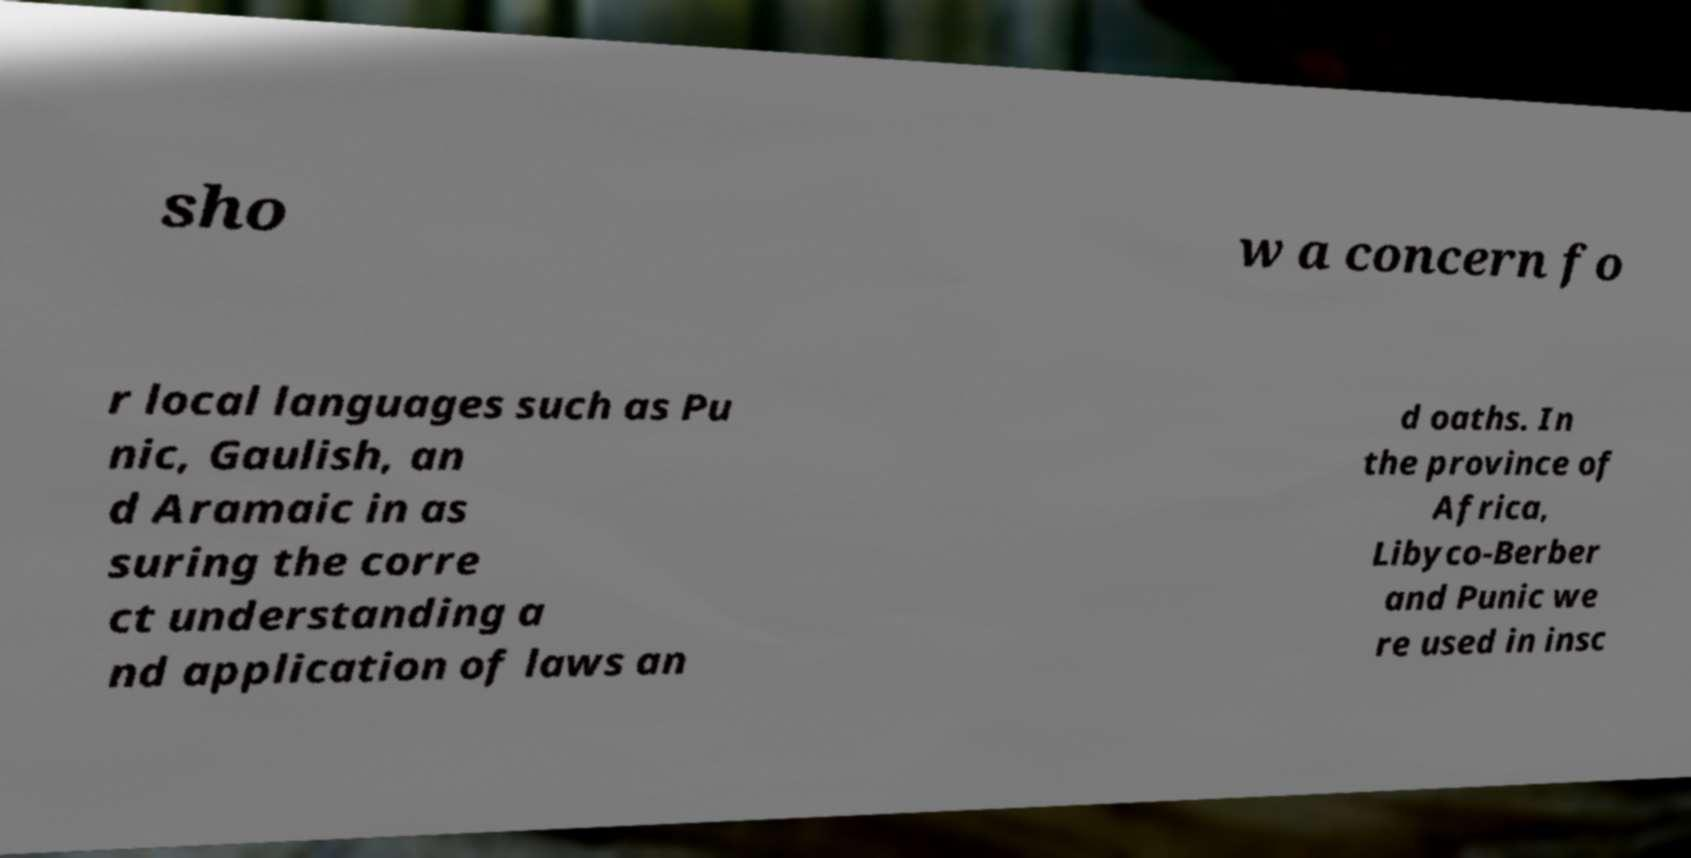Can you read and provide the text displayed in the image?This photo seems to have some interesting text. Can you extract and type it out for me? sho w a concern fo r local languages such as Pu nic, Gaulish, an d Aramaic in as suring the corre ct understanding a nd application of laws an d oaths. In the province of Africa, Libyco-Berber and Punic we re used in insc 